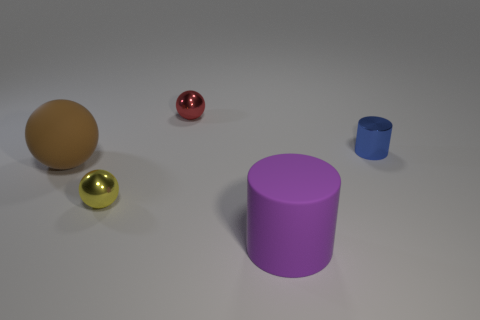There is a brown rubber sphere; is its size the same as the shiny sphere behind the blue cylinder? The brown rubber sphere appears to be larger in size when compared to the shiny red sphere located behind the blue cylinder, judging by their relative proportions and assuming the spheres are at similar distances from the viewpoint. 